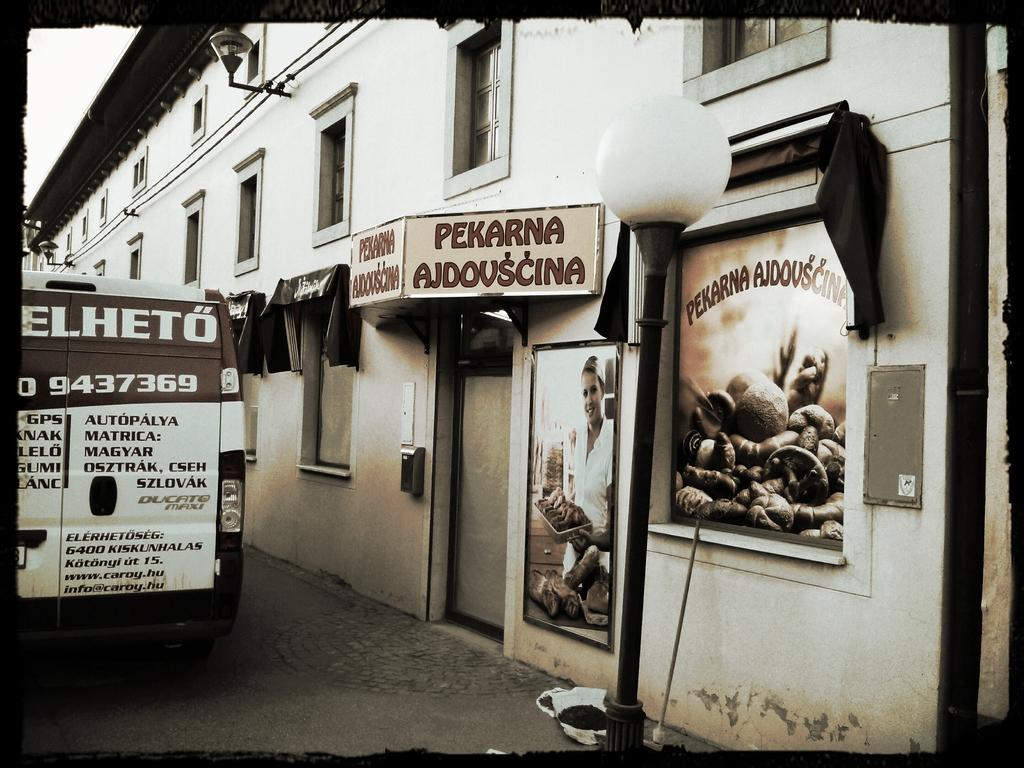Provide a one-sentence caption for the provided image. A black and white photo of the Pekarna Ajdovscina business. 